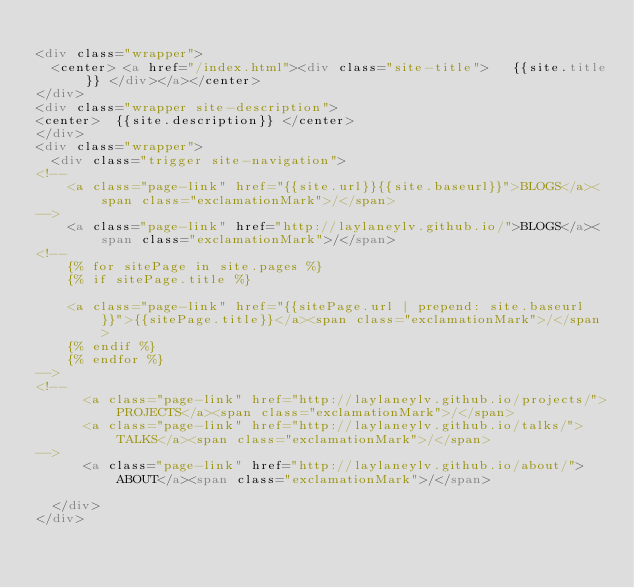<code> <loc_0><loc_0><loc_500><loc_500><_HTML_>
<div class="wrapper">
  <center> <a href="/index.html"><div class="site-title">   {{site.title}} </div></a></center>
</div>
<div class="wrapper site-description">
<center>  {{site.description}} </center>
</div>
<div class="wrapper">
  <div class="trigger site-navigation">
<!--    
    <a class="page-link" href="{{site.url}}{{site.baseurl}}">BLOGS</a><span class="exclamationMark">/</span>
-->
    <a class="page-link" href="http://laylaneylv.github.io/">BLOGS</a><span class="exclamationMark">/</span>
<!--
    {% for sitePage in site.pages %}
    {% if sitePage.title %}

    <a class="page-link" href="{{sitePage.url | prepend: site.baseurl }}">{{sitePage.title}}</a><span class="exclamationMark">/</span>
    {% endif %}
    {% endfor %}
-->
<!--
      <a class="page-link" href="http://laylaneylv.github.io/projects/">PROJECTS</a><span class="exclamationMark">/</span>
      <a class="page-link" href="http://laylaneylv.github.io/talks/">TALKS</a><span class="exclamationMark">/</span>
-->
      <a class="page-link" href="http://laylaneylv.github.io/about/">ABOUT</a><span class="exclamationMark">/</span>
      
  </div>
</div>
</code> 